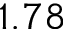<formula> <loc_0><loc_0><loc_500><loc_500>1 . 7 8</formula> 